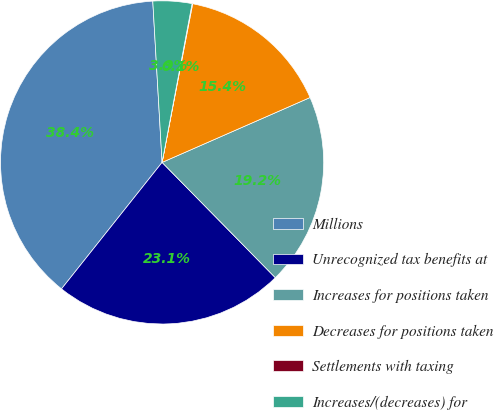Convert chart. <chart><loc_0><loc_0><loc_500><loc_500><pie_chart><fcel>Millions<fcel>Unrecognized tax benefits at<fcel>Increases for positions taken<fcel>Decreases for positions taken<fcel>Settlements with taxing<fcel>Increases/(decreases) for<nl><fcel>38.39%<fcel>23.05%<fcel>19.22%<fcel>15.39%<fcel>0.06%<fcel>3.89%<nl></chart> 